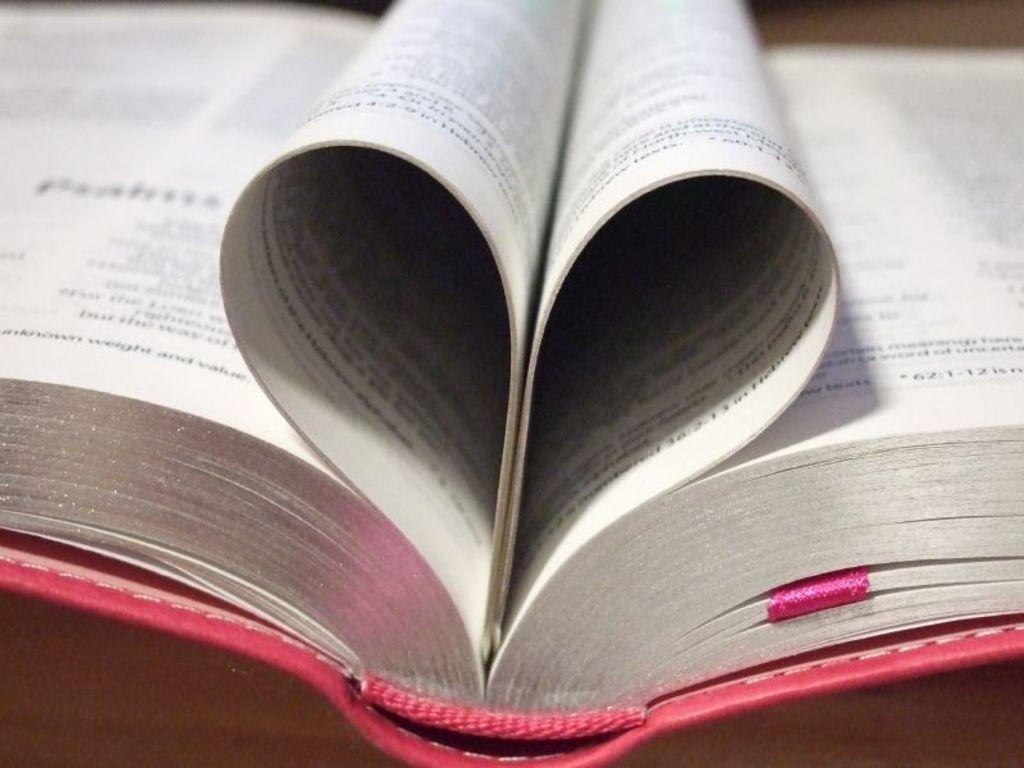<image>
Offer a succinct explanation of the picture presented. The pages of opened book is arranged ina heart shape, but the letters are too blurred to make out, except for "62:1-12" on the right side. 